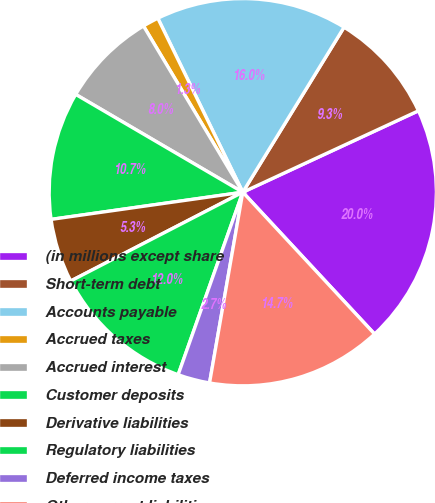Convert chart. <chart><loc_0><loc_0><loc_500><loc_500><pie_chart><fcel>(in millions except share<fcel>Short-term debt<fcel>Accounts payable<fcel>Accrued taxes<fcel>Accrued interest<fcel>Customer deposits<fcel>Derivative liabilities<fcel>Regulatory liabilities<fcel>Deferred income taxes<fcel>Other current liabilities<nl><fcel>19.99%<fcel>9.33%<fcel>15.99%<fcel>1.34%<fcel>8.0%<fcel>10.67%<fcel>5.34%<fcel>12.0%<fcel>2.67%<fcel>14.66%<nl></chart> 